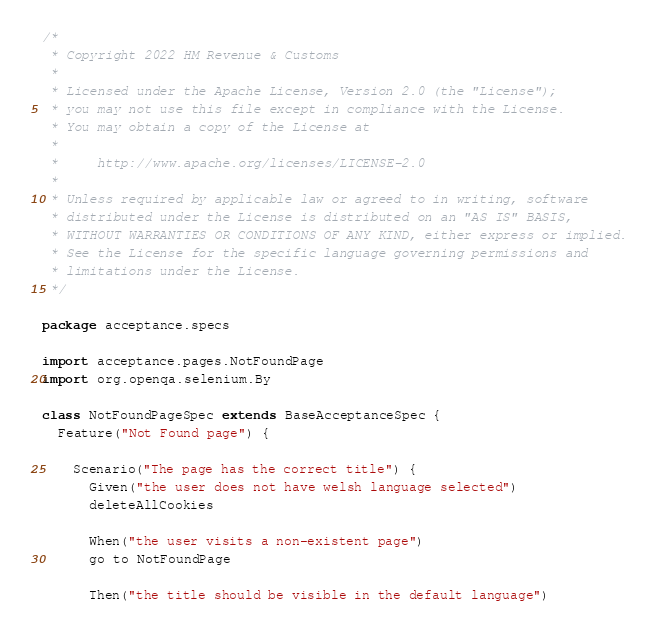Convert code to text. <code><loc_0><loc_0><loc_500><loc_500><_Scala_>/*
 * Copyright 2022 HM Revenue & Customs
 *
 * Licensed under the Apache License, Version 2.0 (the "License");
 * you may not use this file except in compliance with the License.
 * You may obtain a copy of the License at
 *
 *     http://www.apache.org/licenses/LICENSE-2.0
 *
 * Unless required by applicable law or agreed to in writing, software
 * distributed under the License is distributed on an "AS IS" BASIS,
 * WITHOUT WARRANTIES OR CONDITIONS OF ANY KIND, either express or implied.
 * See the License for the specific language governing permissions and
 * limitations under the License.
 */

package acceptance.specs

import acceptance.pages.NotFoundPage
import org.openqa.selenium.By

class NotFoundPageSpec extends BaseAcceptanceSpec {
  Feature("Not Found page") {

    Scenario("The page has the correct title") {
      Given("the user does not have welsh language selected")
      deleteAllCookies

      When("the user visits a non-existent page")
      go to NotFoundPage

      Then("the title should be visible in the default language")</code> 